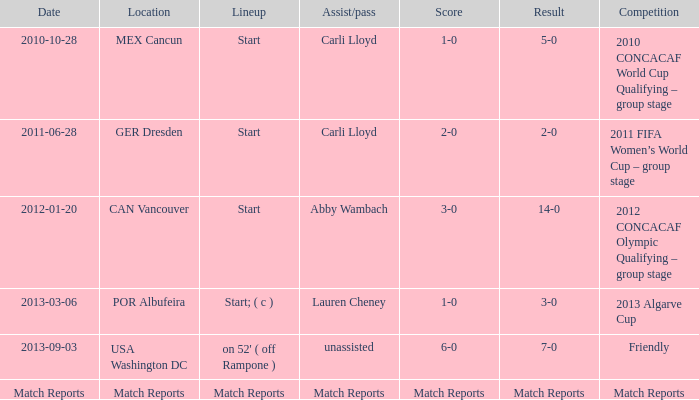In the 2010 concacaf world cup qualifying group stage, which assist/pass contributed to a 1-0 score? Carli Lloyd. 